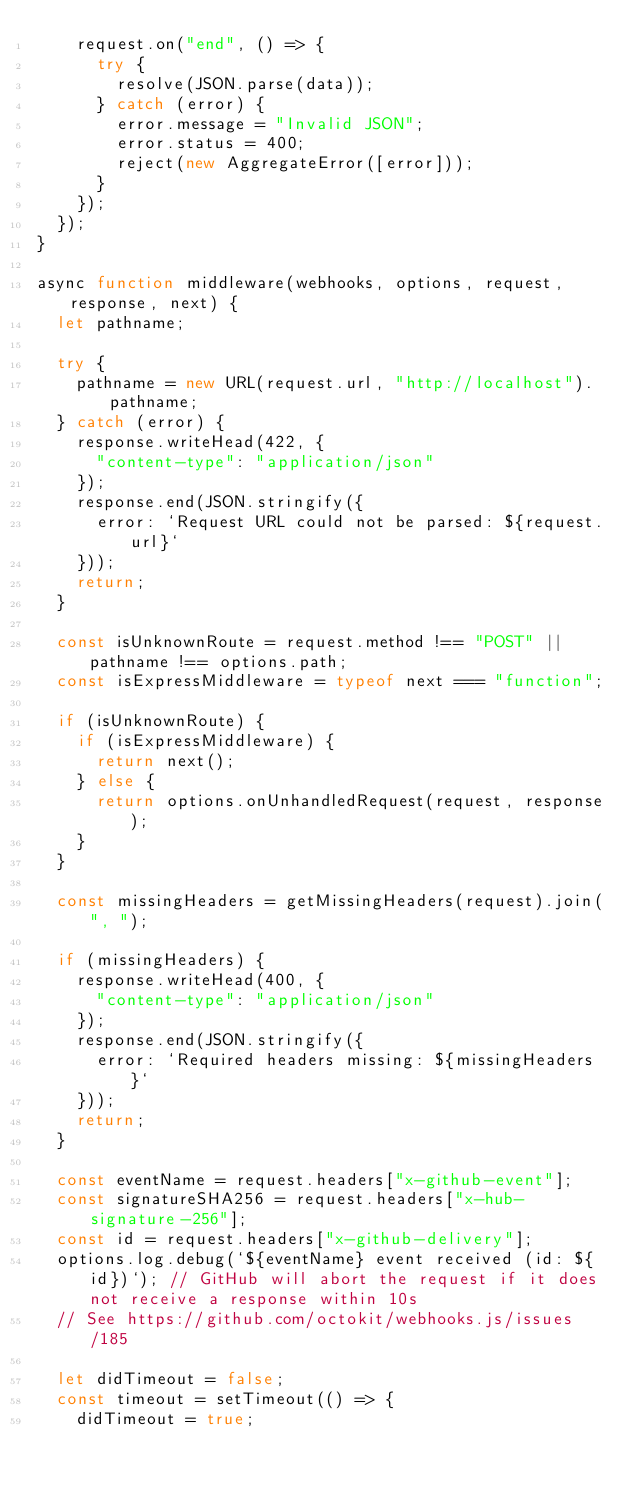<code> <loc_0><loc_0><loc_500><loc_500><_JavaScript_>    request.on("end", () => {
      try {
        resolve(JSON.parse(data));
      } catch (error) {
        error.message = "Invalid JSON";
        error.status = 400;
        reject(new AggregateError([error]));
      }
    });
  });
}

async function middleware(webhooks, options, request, response, next) {
  let pathname;

  try {
    pathname = new URL(request.url, "http://localhost").pathname;
  } catch (error) {
    response.writeHead(422, {
      "content-type": "application/json"
    });
    response.end(JSON.stringify({
      error: `Request URL could not be parsed: ${request.url}`
    }));
    return;
  }

  const isUnknownRoute = request.method !== "POST" || pathname !== options.path;
  const isExpressMiddleware = typeof next === "function";

  if (isUnknownRoute) {
    if (isExpressMiddleware) {
      return next();
    } else {
      return options.onUnhandledRequest(request, response);
    }
  }

  const missingHeaders = getMissingHeaders(request).join(", ");

  if (missingHeaders) {
    response.writeHead(400, {
      "content-type": "application/json"
    });
    response.end(JSON.stringify({
      error: `Required headers missing: ${missingHeaders}`
    }));
    return;
  }

  const eventName = request.headers["x-github-event"];
  const signatureSHA256 = request.headers["x-hub-signature-256"];
  const id = request.headers["x-github-delivery"];
  options.log.debug(`${eventName} event received (id: ${id})`); // GitHub will abort the request if it does not receive a response within 10s
  // See https://github.com/octokit/webhooks.js/issues/185

  let didTimeout = false;
  const timeout = setTimeout(() => {
    didTimeout = true;</code> 